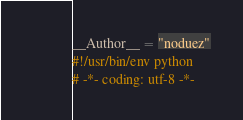Convert code to text. <code><loc_0><loc_0><loc_500><loc_500><_Python_>__Author__ = "noduez"
#!/usr/bin/env python 
# -*- coding: utf-8 -*-</code> 